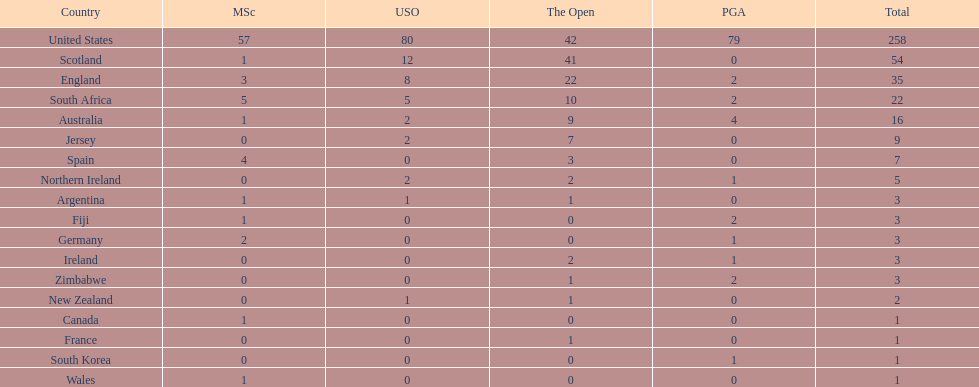Could you parse the entire table as a dict? {'header': ['Country', 'MSc', 'USO', 'The Open', 'PGA', 'Total'], 'rows': [['United States', '57', '80', '42', '79', '258'], ['Scotland', '1', '12', '41', '0', '54'], ['England', '3', '8', '22', '2', '35'], ['South Africa', '5', '5', '10', '2', '22'], ['Australia', '1', '2', '9', '4', '16'], ['Jersey', '0', '2', '7', '0', '9'], ['Spain', '4', '0', '3', '0', '7'], ['Northern Ireland', '0', '2', '2', '1', '5'], ['Argentina', '1', '1', '1', '0', '3'], ['Fiji', '1', '0', '0', '2', '3'], ['Germany', '2', '0', '0', '1', '3'], ['Ireland', '0', '0', '2', '1', '3'], ['Zimbabwe', '0', '0', '1', '2', '3'], ['New Zealand', '0', '1', '1', '0', '2'], ['Canada', '1', '0', '0', '0', '1'], ['France', '0', '0', '1', '0', '1'], ['South Korea', '0', '0', '0', '1', '1'], ['Wales', '1', '0', '0', '0', '1']]} Which african country has the least champion golfers according to this table? Zimbabwe. 